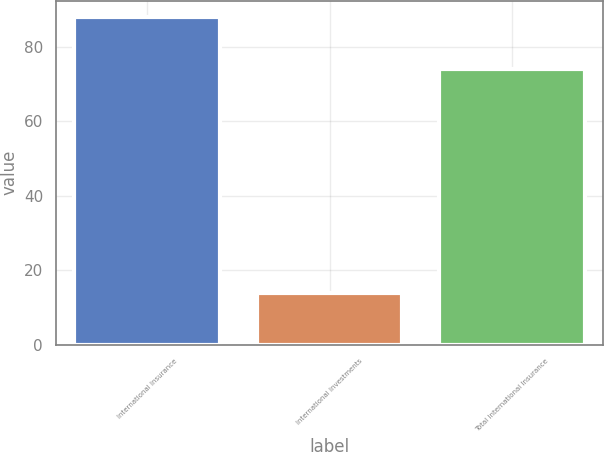<chart> <loc_0><loc_0><loc_500><loc_500><bar_chart><fcel>International Insurance<fcel>International Investments<fcel>Total International Insurance<nl><fcel>88<fcel>14<fcel>74<nl></chart> 